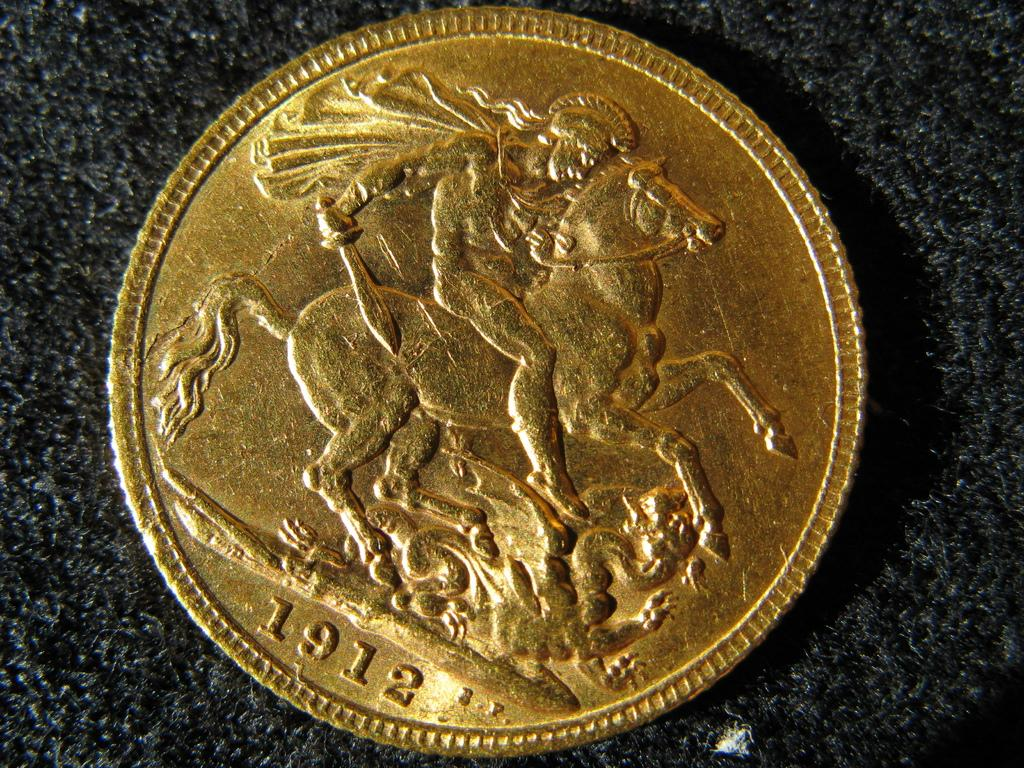<image>
Render a clear and concise summary of the photo. A gold coin featuring a horse and rider with the date 1912 on the bottom 